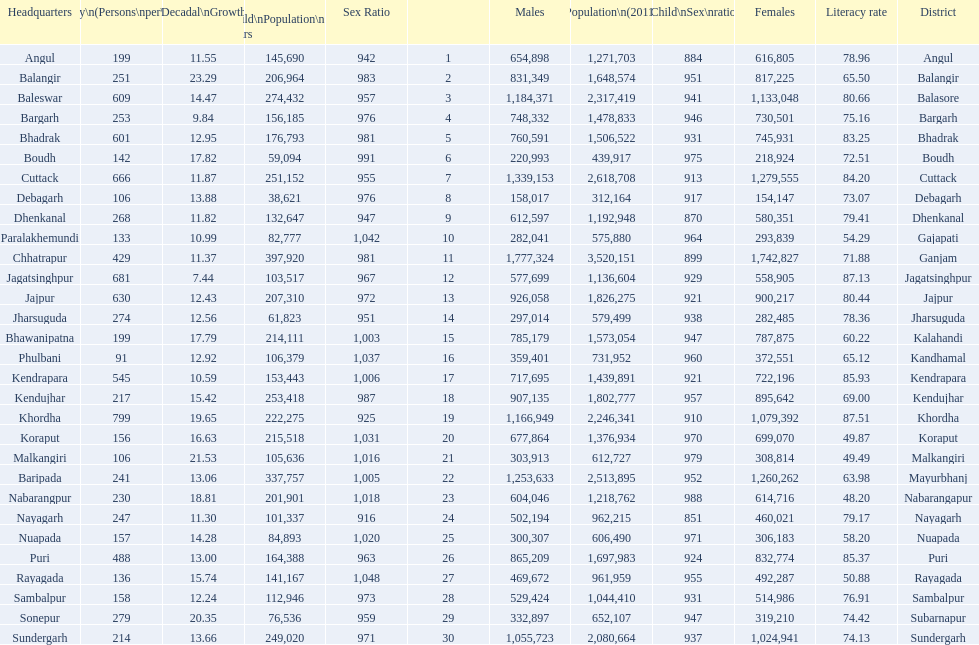How many females live in cuttack? 1,279,555. Parse the full table. {'header': ['Headquarters', 'Density\\n(Persons\\nper\\nkm2)', 'Percentage\\nDecadal\\nGrowth\\n2001-2011', 'Child\\nPopulation\\n0–6 years', 'Sex Ratio', '', 'Males', 'Population\\n(2011)', 'Child\\nSex\\nratio', 'Females', 'Literacy rate', 'District'], 'rows': [['Angul', '199', '11.55', '145,690', '942', '1', '654,898', '1,271,703', '884', '616,805', '78.96', 'Angul'], ['Balangir', '251', '23.29', '206,964', '983', '2', '831,349', '1,648,574', '951', '817,225', '65.50', 'Balangir'], ['Baleswar', '609', '14.47', '274,432', '957', '3', '1,184,371', '2,317,419', '941', '1,133,048', '80.66', 'Balasore'], ['Bargarh', '253', '9.84', '156,185', '976', '4', '748,332', '1,478,833', '946', '730,501', '75.16', 'Bargarh'], ['Bhadrak', '601', '12.95', '176,793', '981', '5', '760,591', '1,506,522', '931', '745,931', '83.25', 'Bhadrak'], ['Boudh', '142', '17.82', '59,094', '991', '6', '220,993', '439,917', '975', '218,924', '72.51', 'Boudh'], ['Cuttack', '666', '11.87', '251,152', '955', '7', '1,339,153', '2,618,708', '913', '1,279,555', '84.20', 'Cuttack'], ['Debagarh', '106', '13.88', '38,621', '976', '8', '158,017', '312,164', '917', '154,147', '73.07', 'Debagarh'], ['Dhenkanal', '268', '11.82', '132,647', '947', '9', '612,597', '1,192,948', '870', '580,351', '79.41', 'Dhenkanal'], ['Paralakhemundi', '133', '10.99', '82,777', '1,042', '10', '282,041', '575,880', '964', '293,839', '54.29', 'Gajapati'], ['Chhatrapur', '429', '11.37', '397,920', '981', '11', '1,777,324', '3,520,151', '899', '1,742,827', '71.88', 'Ganjam'], ['Jagatsinghpur', '681', '7.44', '103,517', '967', '12', '577,699', '1,136,604', '929', '558,905', '87.13', 'Jagatsinghpur'], ['Jajpur', '630', '12.43', '207,310', '972', '13', '926,058', '1,826,275', '921', '900,217', '80.44', 'Jajpur'], ['Jharsuguda', '274', '12.56', '61,823', '951', '14', '297,014', '579,499', '938', '282,485', '78.36', 'Jharsuguda'], ['Bhawanipatna', '199', '17.79', '214,111', '1,003', '15', '785,179', '1,573,054', '947', '787,875', '60.22', 'Kalahandi'], ['Phulbani', '91', '12.92', '106,379', '1,037', '16', '359,401', '731,952', '960', '372,551', '65.12', 'Kandhamal'], ['Kendrapara', '545', '10.59', '153,443', '1,006', '17', '717,695', '1,439,891', '921', '722,196', '85.93', 'Kendrapara'], ['Kendujhar', '217', '15.42', '253,418', '987', '18', '907,135', '1,802,777', '957', '895,642', '69.00', 'Kendujhar'], ['Khordha', '799', '19.65', '222,275', '925', '19', '1,166,949', '2,246,341', '910', '1,079,392', '87.51', 'Khordha'], ['Koraput', '156', '16.63', '215,518', '1,031', '20', '677,864', '1,376,934', '970', '699,070', '49.87', 'Koraput'], ['Malkangiri', '106', '21.53', '105,636', '1,016', '21', '303,913', '612,727', '979', '308,814', '49.49', 'Malkangiri'], ['Baripada', '241', '13.06', '337,757', '1,005', '22', '1,253,633', '2,513,895', '952', '1,260,262', '63.98', 'Mayurbhanj'], ['Nabarangpur', '230', '18.81', '201,901', '1,018', '23', '604,046', '1,218,762', '988', '614,716', '48.20', 'Nabarangapur'], ['Nayagarh', '247', '11.30', '101,337', '916', '24', '502,194', '962,215', '851', '460,021', '79.17', 'Nayagarh'], ['Nuapada', '157', '14.28', '84,893', '1,020', '25', '300,307', '606,490', '971', '306,183', '58.20', 'Nuapada'], ['Puri', '488', '13.00', '164,388', '963', '26', '865,209', '1,697,983', '924', '832,774', '85.37', 'Puri'], ['Rayagada', '136', '15.74', '141,167', '1,048', '27', '469,672', '961,959', '955', '492,287', '50.88', 'Rayagada'], ['Sambalpur', '158', '12.24', '112,946', '973', '28', '529,424', '1,044,410', '931', '514,986', '76.91', 'Sambalpur'], ['Sonepur', '279', '20.35', '76,536', '959', '29', '332,897', '652,107', '947', '319,210', '74.42', 'Subarnapur'], ['Sundergarh', '214', '13.66', '249,020', '971', '30', '1,055,723', '2,080,664', '937', '1,024,941', '74.13', 'Sundergarh']]} 